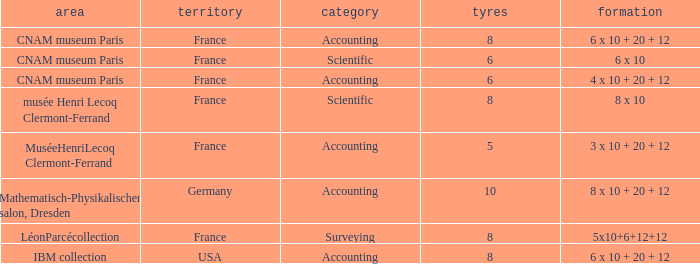What average wheels has accounting as the type, with IBM Collection as the location? 8.0. 